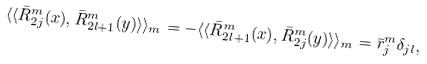Convert formula to latex. <formula><loc_0><loc_0><loc_500><loc_500>\langle \langle { \bar { R } } ^ { m } _ { 2 j } ( x ) , { \bar { R } } ^ { m } _ { 2 l + 1 } ( y ) \rangle \rangle _ { m } = - \langle \langle { \bar { R } } ^ { m } _ { 2 l + 1 } ( x ) , { \bar { R } } ^ { m } _ { 2 j } ( y ) \rangle \rangle _ { m } = { \bar { r } } ^ { m } _ { j } \delta _ { j l } ,</formula> 